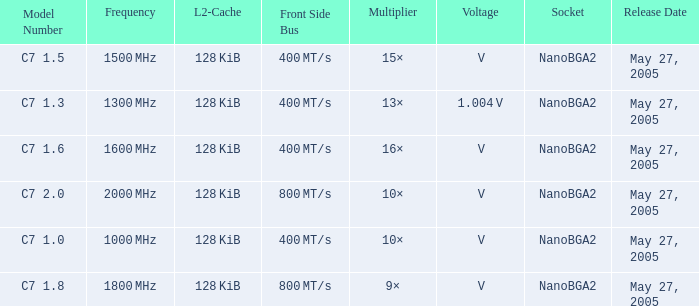What is the Front Side Bus for Model Number c7 1.5? 400 MT/s. Can you give me this table as a dict? {'header': ['Model Number', 'Frequency', 'L2-Cache', 'Front Side Bus', 'Multiplier', 'Voltage', 'Socket', 'Release Date'], 'rows': [['C7 1.5', '1500\u2009MHz', '128\u2009KiB', '400\u2009MT/s', '15×', '\u2009V', 'NanoBGA2', 'May 27, 2005'], ['C7 1.3', '1300\u2009MHz', '128\u2009KiB', '400\u2009MT/s', '13×', '1.004\u2009V', 'NanoBGA2', 'May 27, 2005'], ['C7 1.6', '1600\u2009MHz', '128\u2009KiB', '400\u2009MT/s', '16×', '\u2009V', 'NanoBGA2', 'May 27, 2005'], ['C7 2.0', '2000\u2009MHz', '128\u2009KiB', '800\u2009MT/s', '10×', '\u2009V', 'NanoBGA2', 'May 27, 2005'], ['C7 1.0', '1000\u2009MHz', '128\u2009KiB', '400\u2009MT/s', '10×', '\u2009V', 'NanoBGA2', 'May 27, 2005'], ['C7 1.8', '1800\u2009MHz', '128\u2009KiB', '800\u2009MT/s', '9×', '\u2009V', 'NanoBGA2', 'May 27, 2005']]} 